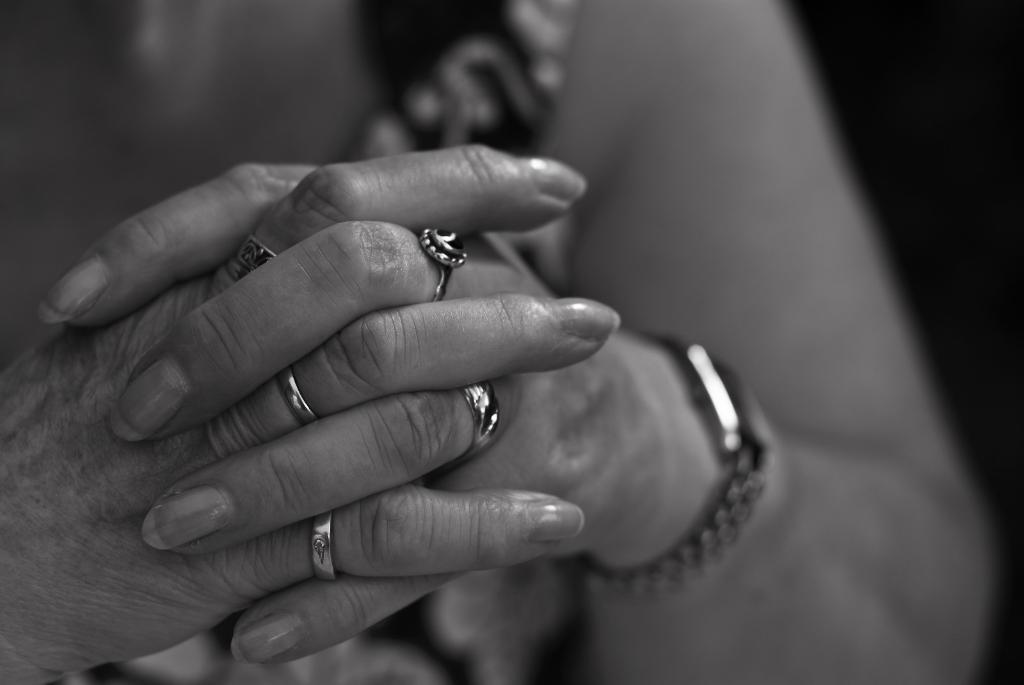What body part is visible in the image? There are fingers of a person in the image. What accessories are visible on the fingers? The person is wearing rings on their fingers. What time-telling device is visible on the wrist? There is a watch on the wrist in the image. What type of pear is being served in the soup in the image? There is no pear or soup present in the image; it only features fingers, rings, and a watch. 